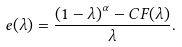<formula> <loc_0><loc_0><loc_500><loc_500>e ( \lambda ) = \frac { \left ( 1 - \lambda \right ) ^ { \alpha } - C F ( \lambda ) } { \lambda } .</formula> 